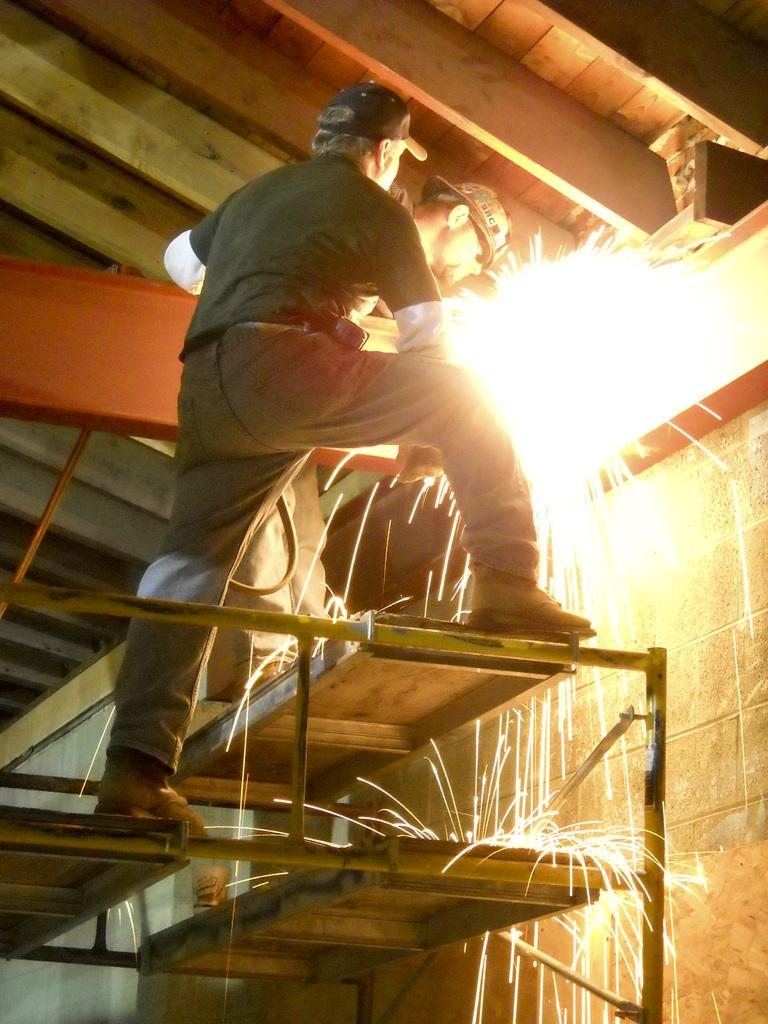How many people are present in the image? There are two people in the image. What is the primary element in the image? Fire is the primary element in the image. What type of structure is visible in the image? There is a wall and a roof in the image, suggesting a building or shelter. Can you describe the unspecified objects in the image? Unfortunately, the facts provided do not specify the nature of the unspecified objects in the image. What thoughts are going through the minds of the people in the image? There is no information provided about the thoughts of the people in the image. What historical event is being depicted in the image? There is no indication of any historical event being depicted in the image. 